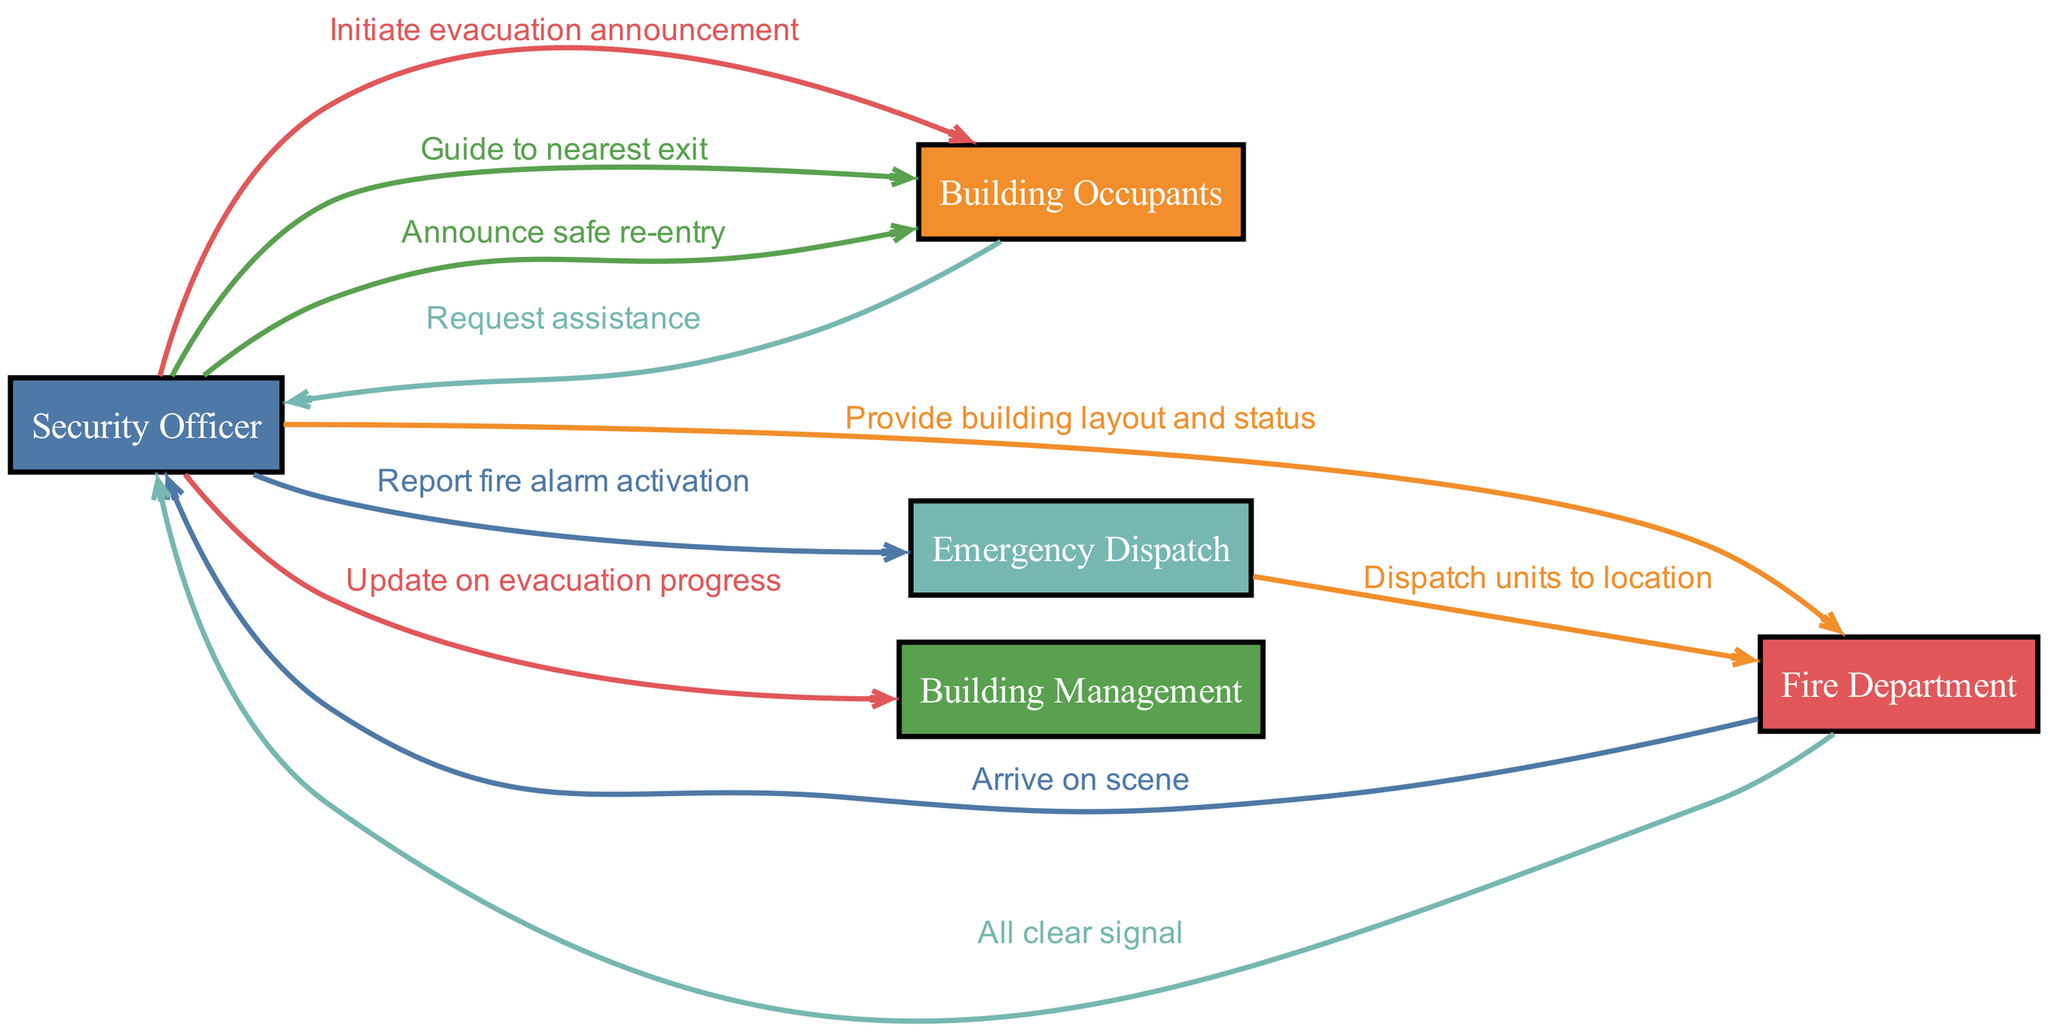What is the first action taken by the Security Officer? The Security Officer's first action is to "Report fire alarm activation" to the Emergency Dispatch. This is the initial communication that begins the sequence of events in the diagram.
Answer: Report fire alarm activation How many actors are involved in the evacuation sequence? There are five distinct actors involved in the sequence: Security Officer, Building Occupants, Fire Department, Emergency Dispatch, and Building Management. By counting the unique actors listed, we confirm this total.
Answer: Five What message does the Fire Department send back to the Security Officer after arriving? The Fire Department sends the message "Arrive on scene" to the Security Officer after they have reached the building. This indicates their presence and readiness to assist.
Answer: Arrive on scene Who does the Security Officer guide to the nearest exit? The Security Officer guides the Building Occupants to the nearest exit, as indicated by the communication in the sequence. The flow suggests that they take responsibility for the occupants during the evacuation.
Answer: Building Occupants What is the last action communicated to the Building Occupants? The last action communicated to the Building Occupants is the announcement of "safe re-entry." This indicates that the evacuation has concluded successfully and it is now safe to return inside the building.
Answer: Announce safe re-entry Which actor is responsible for notifying the Fire Department about the fire alarm? The Security Officer is responsible for notifying the Fire Department by reporting the fire alarm activation via the Emergency Dispatch. This indicates their role in the initial response to the emergency.
Answer: Security Officer How many messages are sent from the Security Officer in the diagram? The Security Officer sends four messages throughout the sequence: reporting the alarm, initiating evacuation, guiding occupants, and updating Building Management. By counting the arrows directed from the Security Officer, we determine this total.
Answer: Four What is the purpose of the message from the Fire Department to the Security Officer after the emergency? The message from the Fire Department to the Security Officer after the emergency is "All clear signal." This serves as a communication confirming that the situation is under control and safe for the occupants.
Answer: All clear signal 